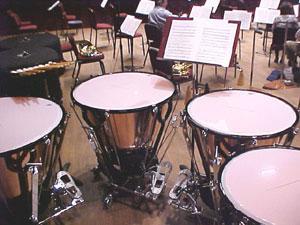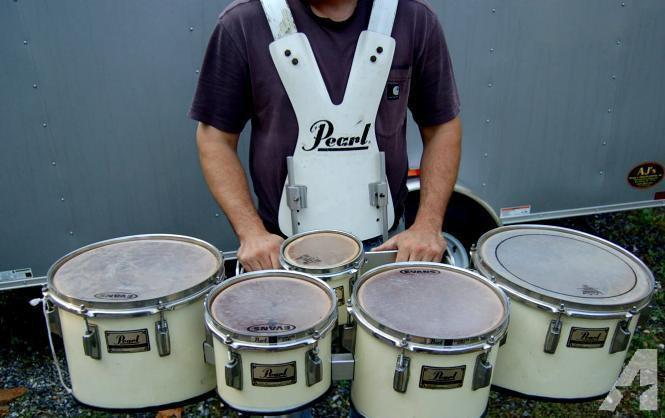The first image is the image on the left, the second image is the image on the right. For the images shown, is this caption "An image includes at least one person wearing a type of harness and standing behind a set of connected drums with four larger drums in front of two smaller ones." true? Answer yes or no. Yes. The first image is the image on the left, the second image is the image on the right. Considering the images on both sides, is "The image on the right shows a single person playing a drum kit with drumsticks." valid? Answer yes or no. No. 